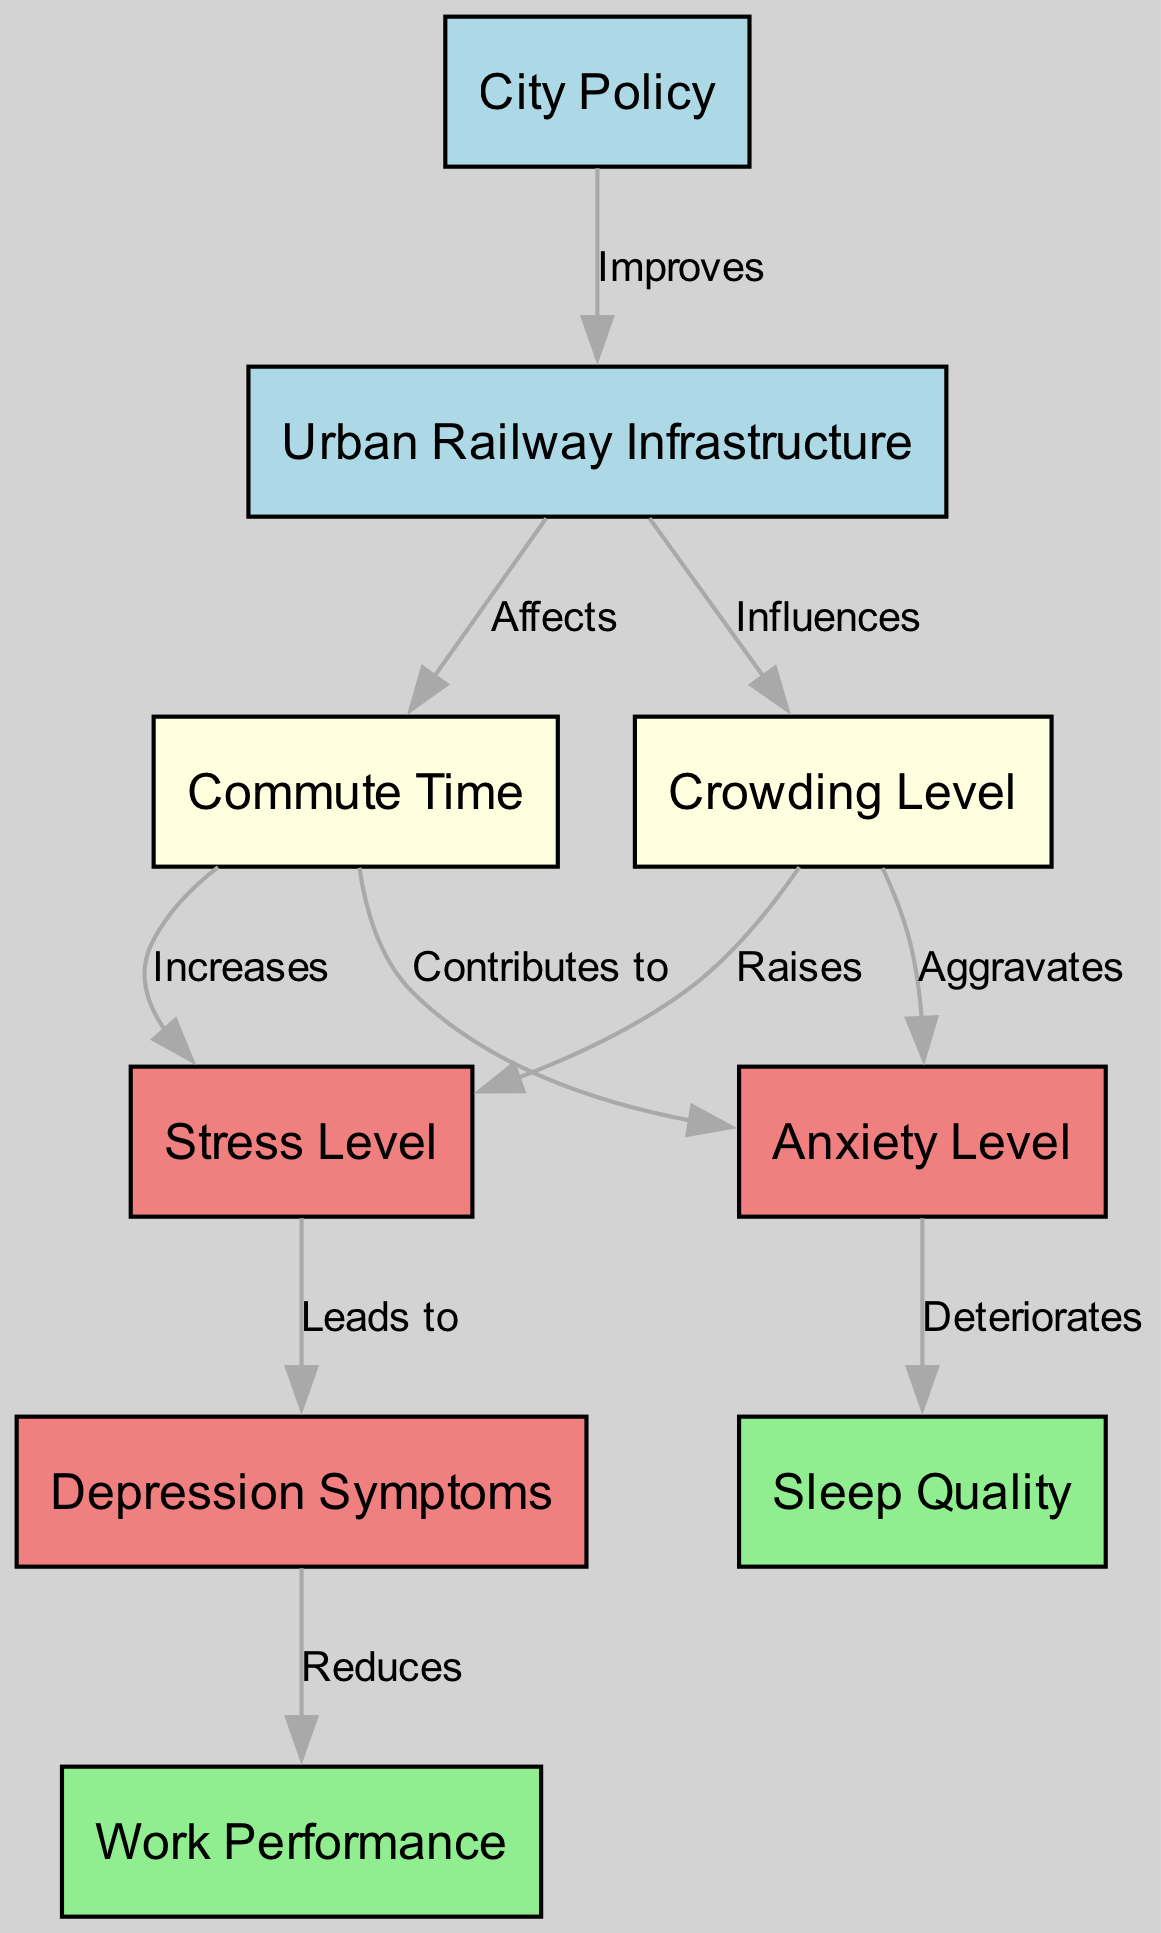What is the first node in the diagram? The diagram starts with the node labeled "Commute Time." I identified this by reviewing the hierarchy of the nodes, where "Commute Time" is at the top level, indicating its primary role.
Answer: Commute Time How many nodes are in the diagram? By counting all nodes listed in the data, there are a total of eight distinct nodes present.
Answer: 8 What effect does "commute time" have on "stress level"? The diagram illustrates a directed edge from "Commute Time" to "Stress Level," labeled "Increases," indicating a positive relationship where longer commute times elevate stress levels.
Answer: Increases What is the relationship between "crowding level" and "anxiety level"? There is a directed edge from "Crowding Level" to "Anxiety Level" in the diagram, labeled "Aggravates," suggesting that higher crowding levels worsen anxiety levels.
Answer: Aggravates What symptoms are affected by "stress level"? The diagram shows a direct connection where "Stress Level" leads to "Depression Symptoms," indicating that increased stress can cause more depressive symptoms.
Answer: Depression Symptoms Which factor can improve "urban railway infrastructure"? The diagram indicates that "City Policy" has a directed edge towards "Urban Railway Infrastructure," labeled "Improves," showing that effective policies can enhance railway systems.
Answer: Improves What are the consequences of "anxiety level" on "sleep quality"? The diagram shows that "Anxiety Level" deteriorates "Sleep Quality," signifying that increased anxiety negatively impacts the quality of sleep.
Answer: Deteriorates How does "urban railway infrastructure" influence "commute time"? The diagram features a directed edge from "Urban Railway Infrastructure" to "Commute Time," labeled "Affects," indicating that the state of the railway infrastructure can change how long commutes take.
Answer: Affects What is the end effect of "depression symptoms" on "work performance"? The diagram connects "Depression Symptoms" to "Work Performance," labeled "Reduces," revealing that increased depressive symptoms can lead to lower work performance.
Answer: Reduces 